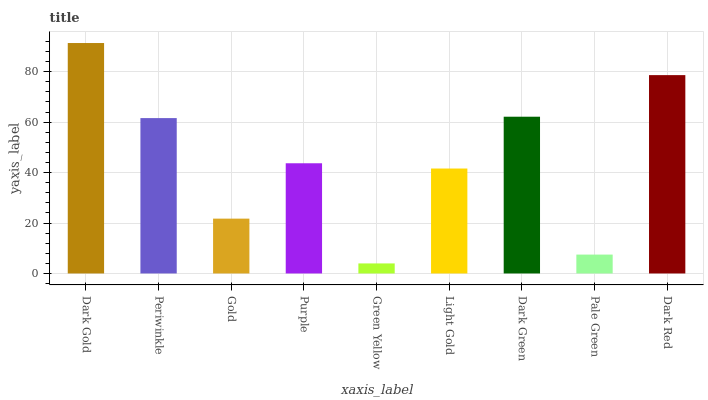Is Periwinkle the minimum?
Answer yes or no. No. Is Periwinkle the maximum?
Answer yes or no. No. Is Dark Gold greater than Periwinkle?
Answer yes or no. Yes. Is Periwinkle less than Dark Gold?
Answer yes or no. Yes. Is Periwinkle greater than Dark Gold?
Answer yes or no. No. Is Dark Gold less than Periwinkle?
Answer yes or no. No. Is Purple the high median?
Answer yes or no. Yes. Is Purple the low median?
Answer yes or no. Yes. Is Dark Gold the high median?
Answer yes or no. No. Is Light Gold the low median?
Answer yes or no. No. 